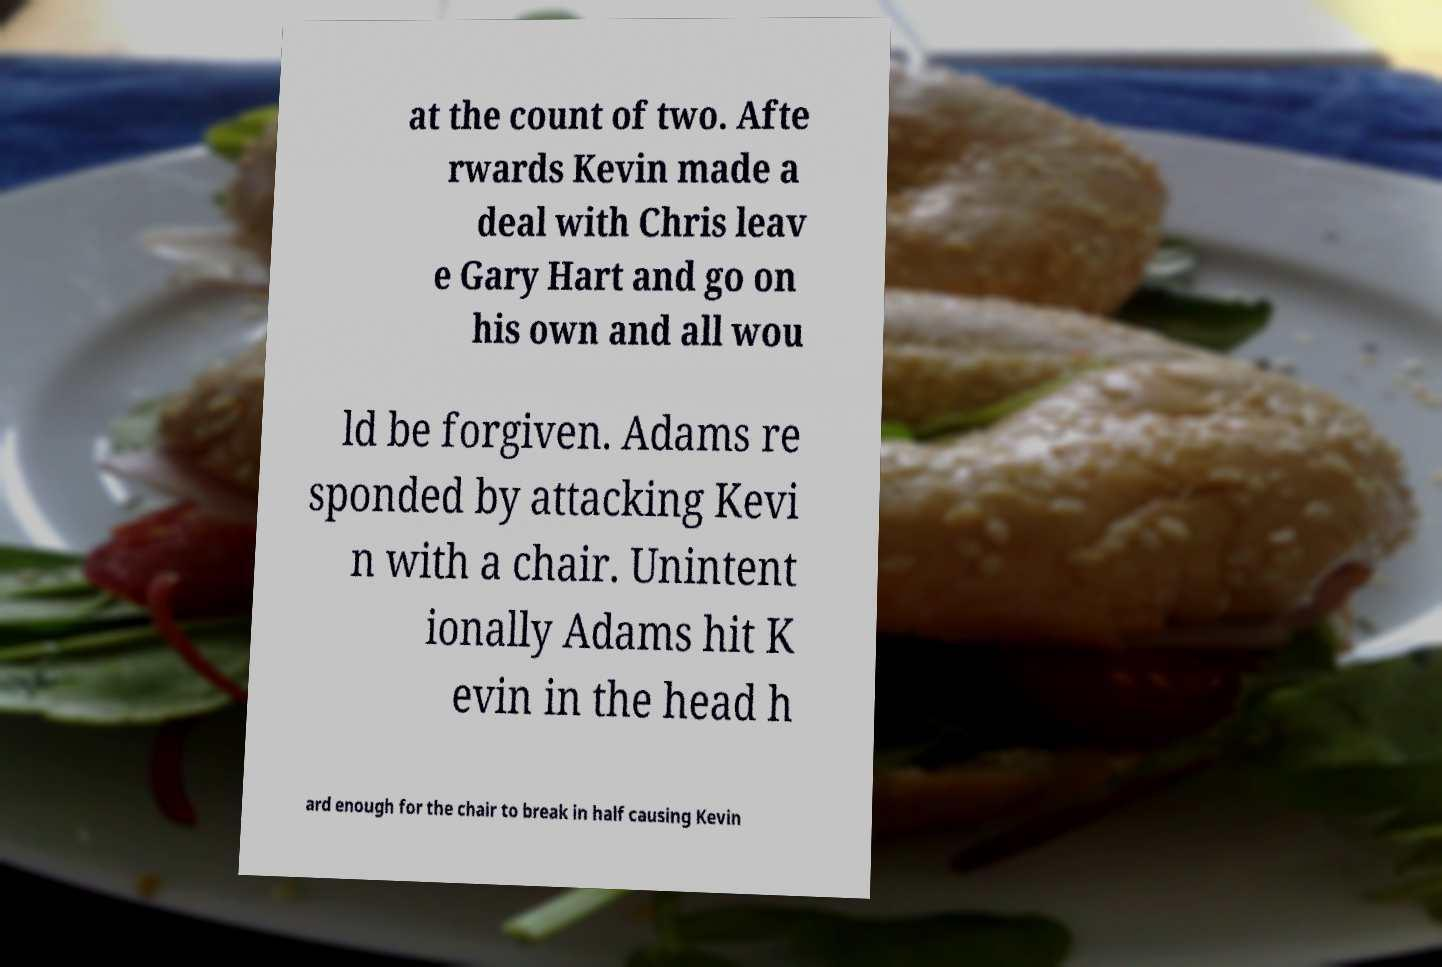There's text embedded in this image that I need extracted. Can you transcribe it verbatim? at the count of two. Afte rwards Kevin made a deal with Chris leav e Gary Hart and go on his own and all wou ld be forgiven. Adams re sponded by attacking Kevi n with a chair. Unintent ionally Adams hit K evin in the head h ard enough for the chair to break in half causing Kevin 